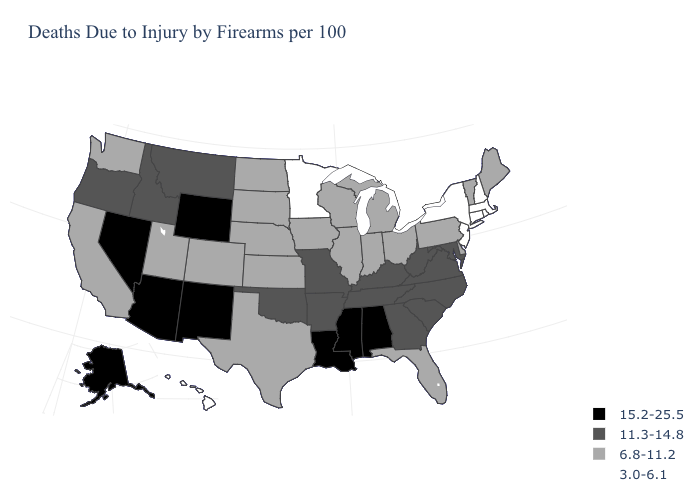What is the value of Delaware?
Keep it brief. 6.8-11.2. How many symbols are there in the legend?
Keep it brief. 4. What is the value of Florida?
Short answer required. 6.8-11.2. Does North Dakota have a higher value than Colorado?
Keep it brief. No. Does Alaska have the lowest value in the West?
Answer briefly. No. Among the states that border Iowa , does Missouri have the highest value?
Keep it brief. Yes. What is the lowest value in the West?
Write a very short answer. 3.0-6.1. Name the states that have a value in the range 15.2-25.5?
Be succinct. Alabama, Alaska, Arizona, Louisiana, Mississippi, Nevada, New Mexico, Wyoming. What is the lowest value in the USA?
Concise answer only. 3.0-6.1. Name the states that have a value in the range 3.0-6.1?
Be succinct. Connecticut, Hawaii, Massachusetts, Minnesota, New Hampshire, New Jersey, New York, Rhode Island. What is the lowest value in the USA?
Be succinct. 3.0-6.1. Name the states that have a value in the range 6.8-11.2?
Give a very brief answer. California, Colorado, Delaware, Florida, Illinois, Indiana, Iowa, Kansas, Maine, Michigan, Nebraska, North Dakota, Ohio, Pennsylvania, South Dakota, Texas, Utah, Vermont, Washington, Wisconsin. Name the states that have a value in the range 3.0-6.1?
Write a very short answer. Connecticut, Hawaii, Massachusetts, Minnesota, New Hampshire, New Jersey, New York, Rhode Island. Does Massachusetts have the lowest value in the USA?
Short answer required. Yes. What is the value of Vermont?
Write a very short answer. 6.8-11.2. 